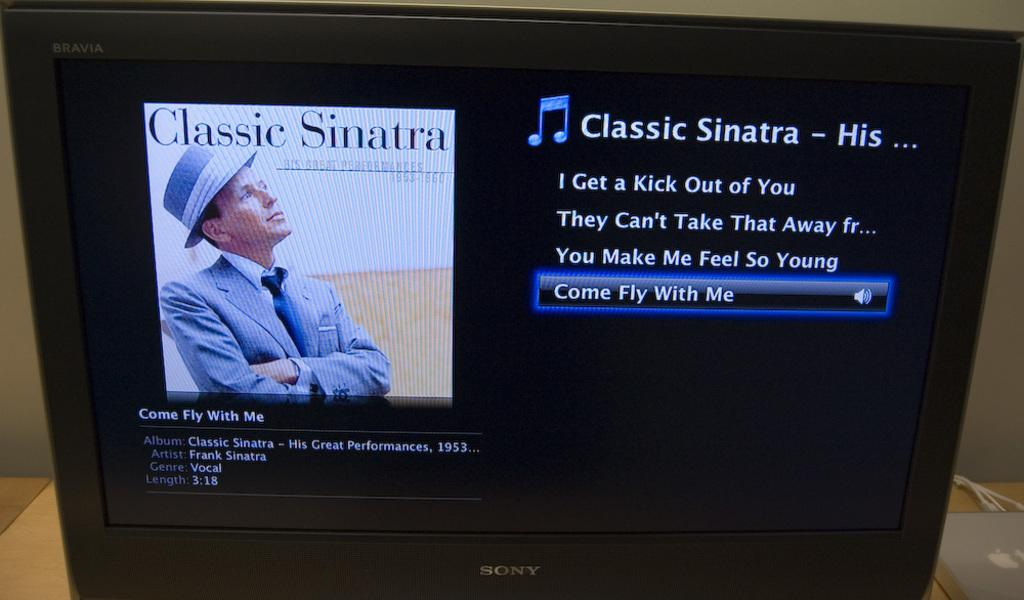<image>
Summarize the visual content of the image. an album that has the words classic sinatra on it 